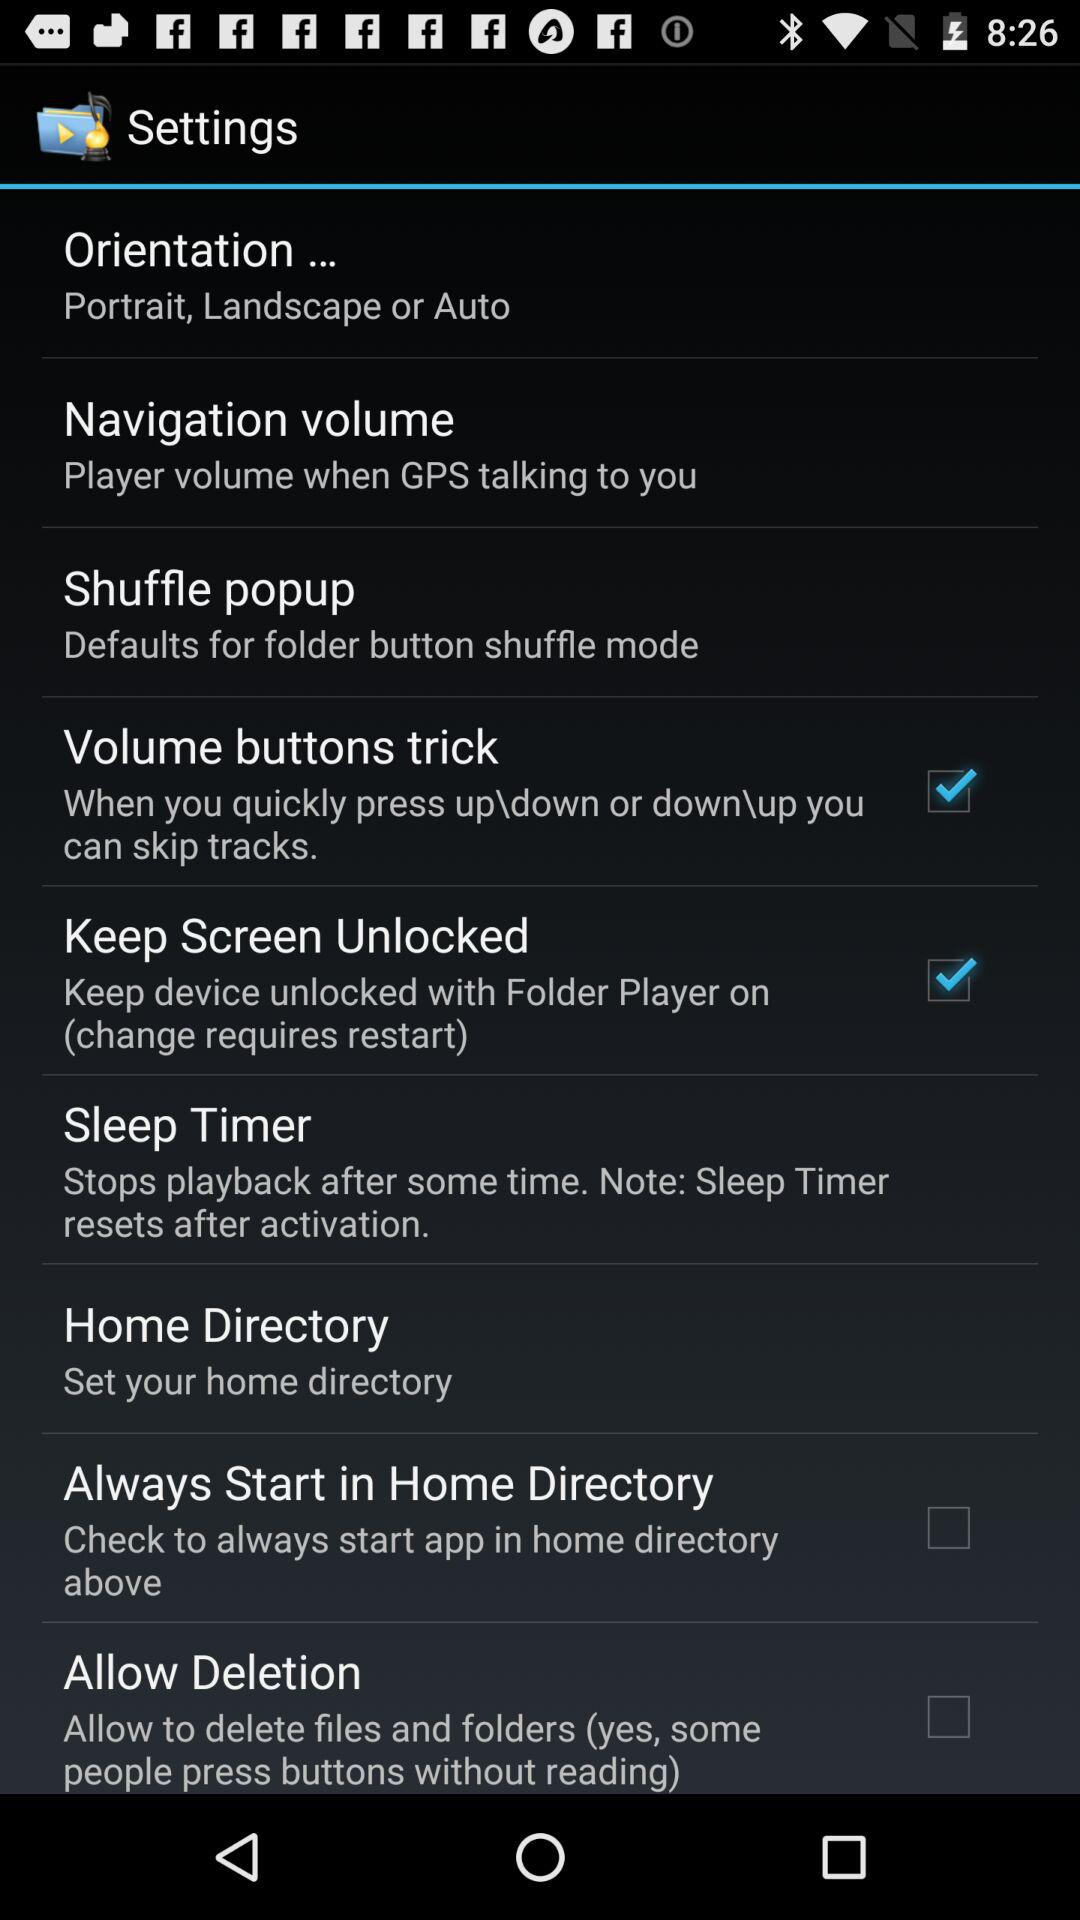What is the status of the home directory?
When the provided information is insufficient, respond with <no answer>. <no answer> 